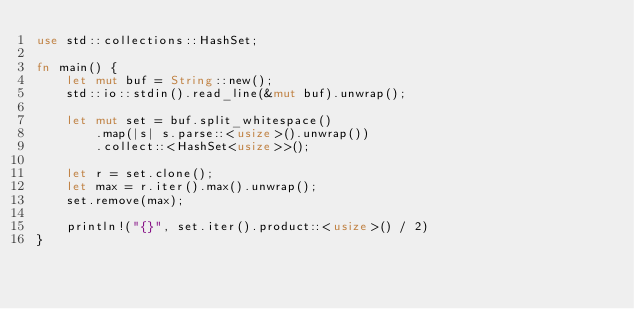Convert code to text. <code><loc_0><loc_0><loc_500><loc_500><_Rust_>use std::collections::HashSet;

fn main() {
    let mut buf = String::new();
    std::io::stdin().read_line(&mut buf).unwrap();

    let mut set = buf.split_whitespace()
        .map(|s| s.parse::<usize>().unwrap())
        .collect::<HashSet<usize>>();

    let r = set.clone();
    let max = r.iter().max().unwrap();
    set.remove(max);

    println!("{}", set.iter().product::<usize>() / 2)
}
</code> 